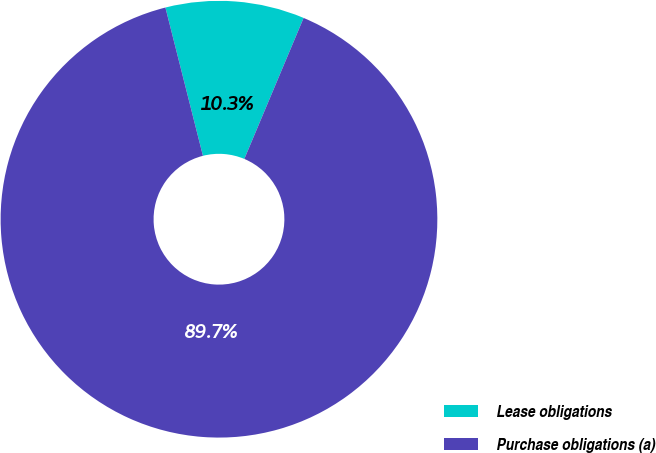Convert chart to OTSL. <chart><loc_0><loc_0><loc_500><loc_500><pie_chart><fcel>Lease obligations<fcel>Purchase obligations (a)<nl><fcel>10.28%<fcel>89.72%<nl></chart> 